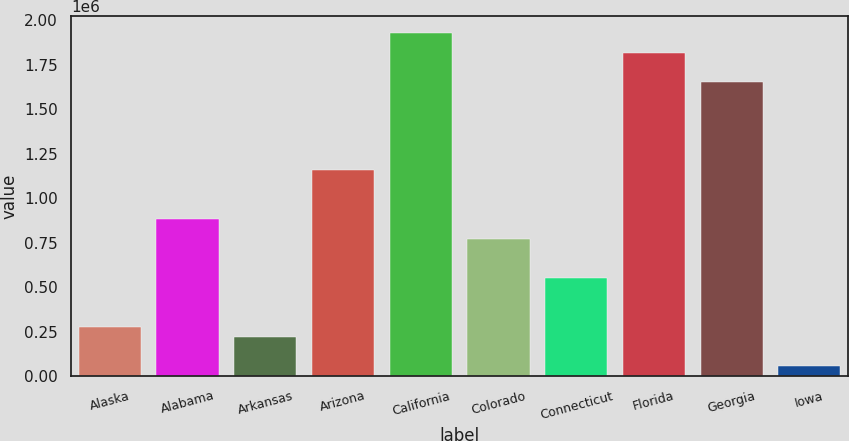Convert chart. <chart><loc_0><loc_0><loc_500><loc_500><bar_chart><fcel>Alaska<fcel>Alabama<fcel>Arkansas<fcel>Arizona<fcel>California<fcel>Colorado<fcel>Connecticut<fcel>Florida<fcel>Georgia<fcel>Iowa<nl><fcel>275784<fcel>881017<fcel>220763<fcel>1.15612e+06<fcel>1.92642e+06<fcel>770974<fcel>550890<fcel>1.81638e+06<fcel>1.65131e+06<fcel>55700.1<nl></chart> 